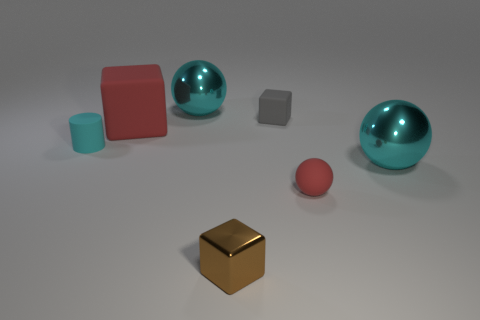Subtract all tiny cubes. How many cubes are left? 1 Subtract all brown cubes. How many cubes are left? 2 Subtract 2 balls. How many balls are left? 1 Subtract all yellow cylinders. Subtract all purple blocks. How many cylinders are left? 1 Subtract all green blocks. How many purple cylinders are left? 0 Subtract all gray matte objects. Subtract all big red matte blocks. How many objects are left? 5 Add 4 rubber cubes. How many rubber cubes are left? 6 Add 6 tiny gray balls. How many tiny gray balls exist? 6 Add 2 big red rubber blocks. How many objects exist? 9 Subtract 0 blue balls. How many objects are left? 7 